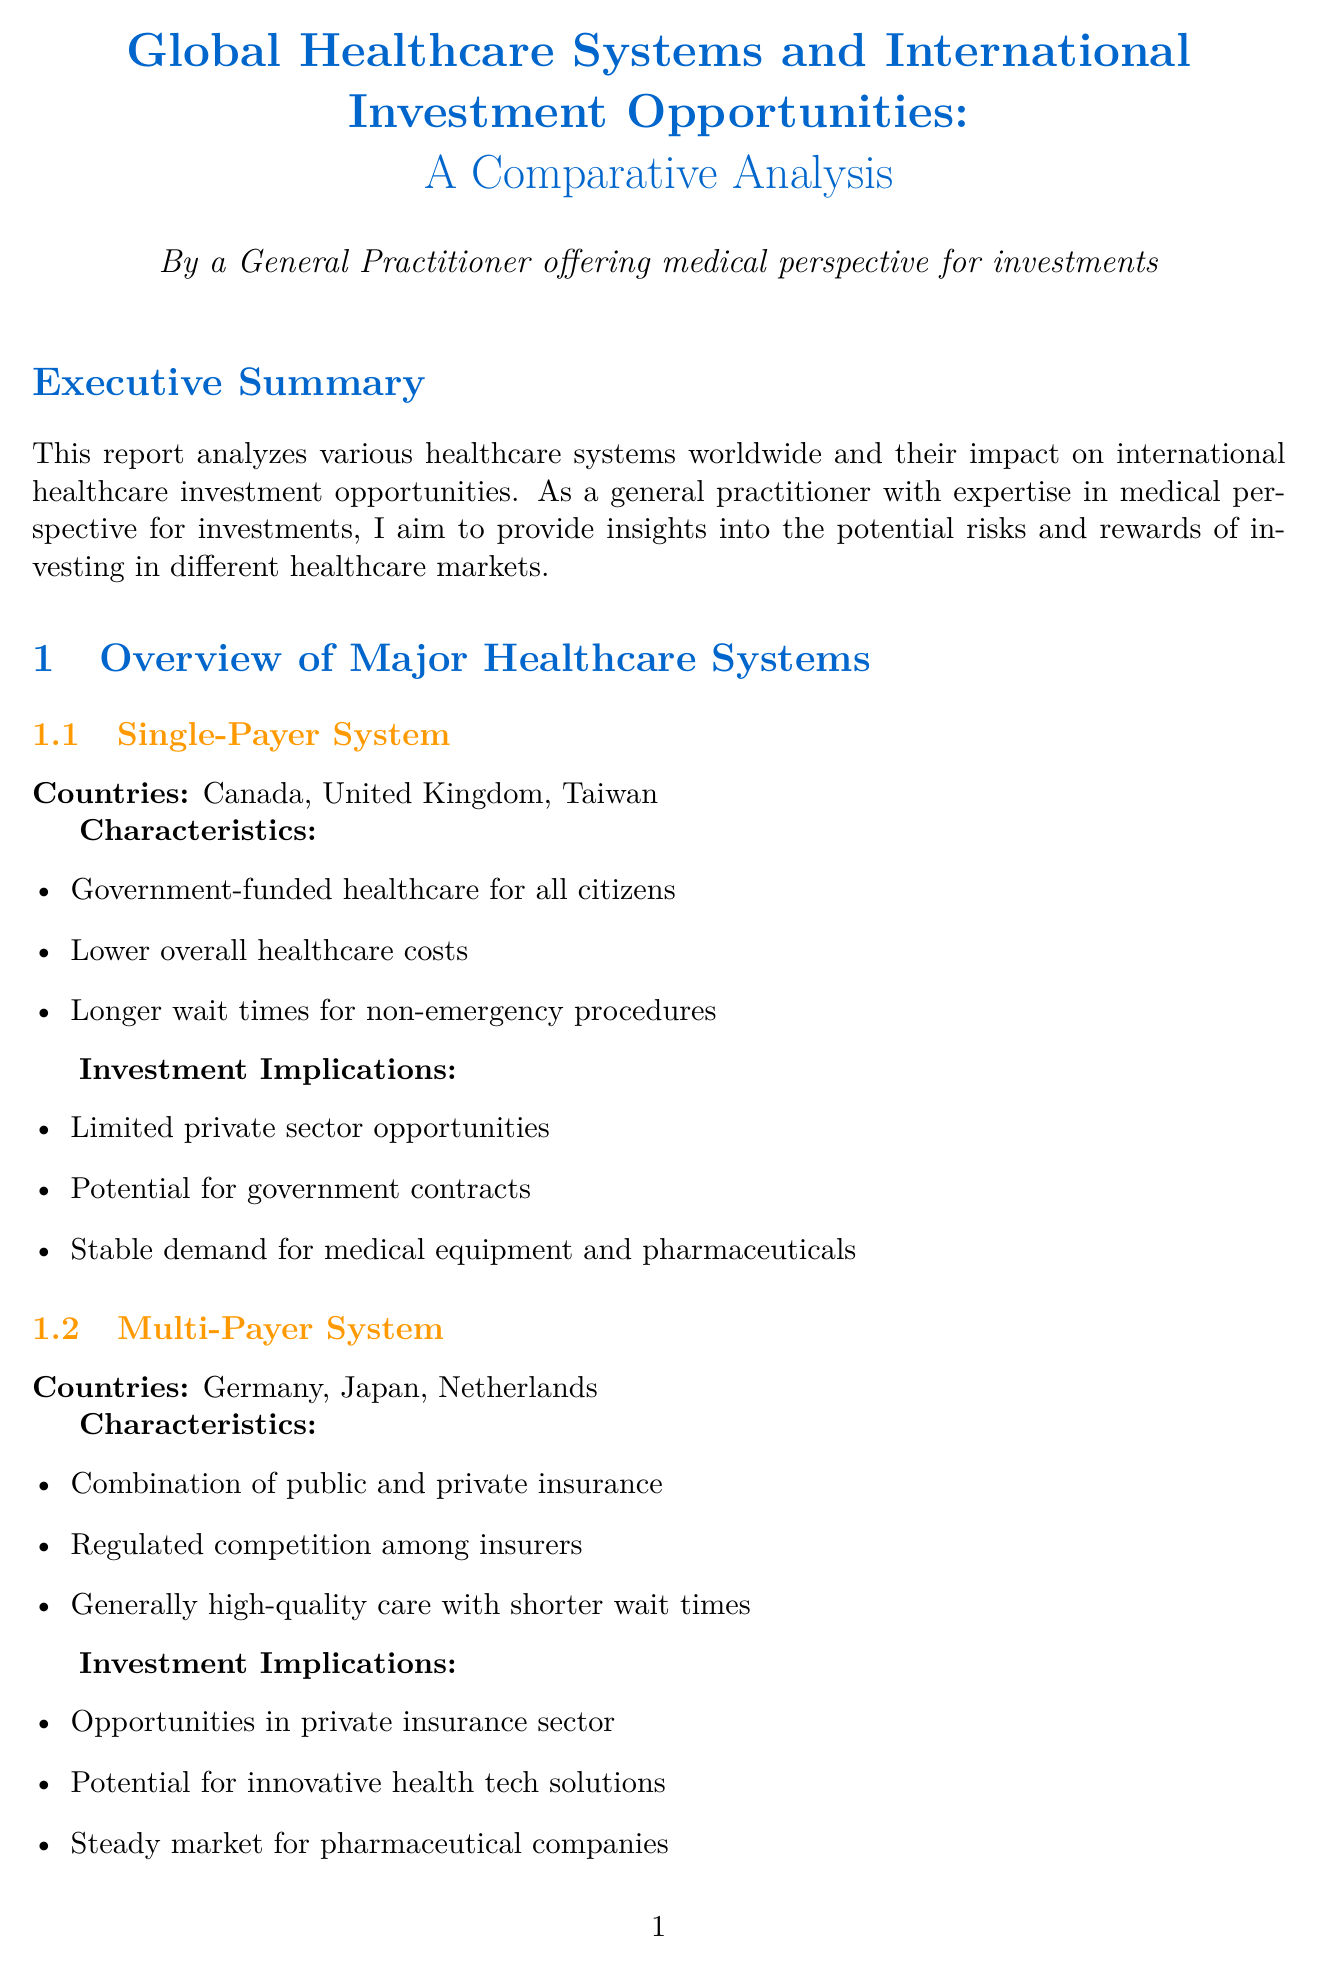What are the three characteristics of the Single-Payer System? The report lists characteristics for each healthcare system, including the Single-Payer System.
Answer: Government-funded healthcare for all citizens, Lower overall healthcare costs, Longer wait times for non-emergency procedures Which countries utilize the Multi-Payer System? The document provides a specific list of countries for each healthcare system, including the Multi-Payer System.
Answer: Germany, Japan, Netherlands What is the investment implication of an Out-of-Pocket System? The report highlights various investment implications for each healthcare system, including the Out-of-Pocket System.
Answer: High potential for private hospital chains What are the two sectors with opportunities in North America? The investment opportunities section details promising sectors per region, including North America.
Answer: Telemedicine, Personalized Medicine What does the Infant Mortality Rate indicator indicate? The report describes each key performance indicator and its relevance, specifically for the Infant Mortality Rate.
Answer: Indicates quality of prenatal and postnatal care 